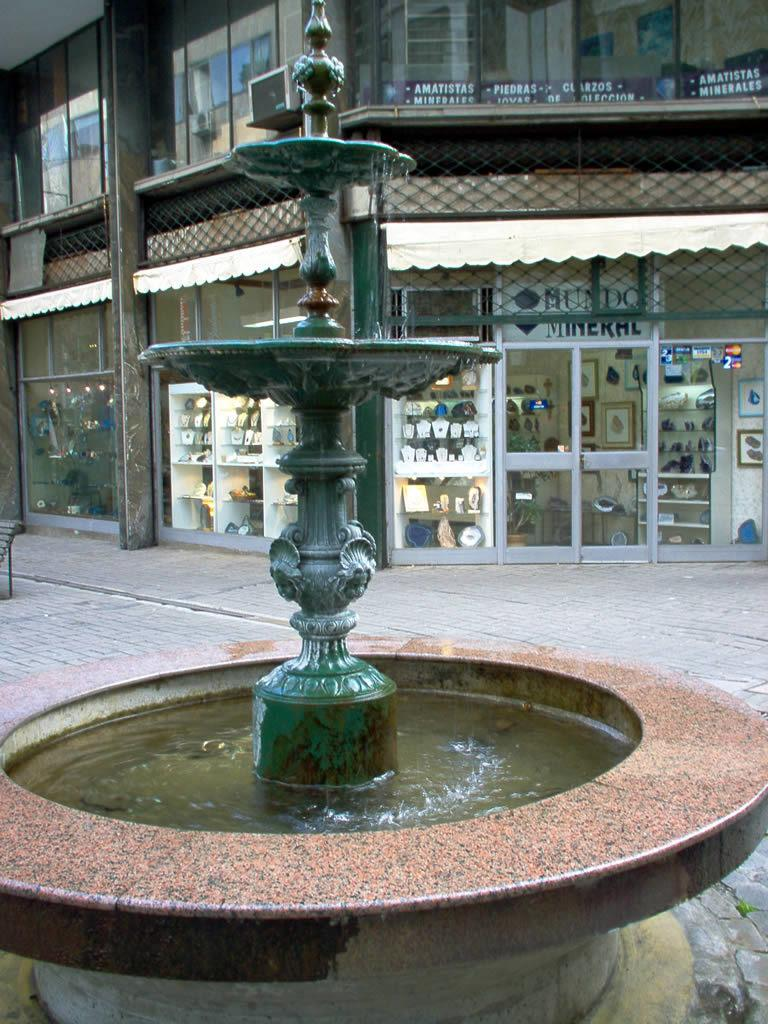What is the main feature in the image? There is a fountain with water in the image. What is located behind the fountain? There is a footpath behind the fountain. What can be seen in the background of the image? There is a building with stores in the background of the image. What type of material is used for the building's windows? Glasses are present on the building. What is the structure of the building? The building has a roof and walls. What type of rod is being used to stir the liquid in the fountain? There is no rod or liquid present in the fountain; it is a fountain with water. What type of doll is sitting on the roof of the building? There is no doll present on the roof of the building. 